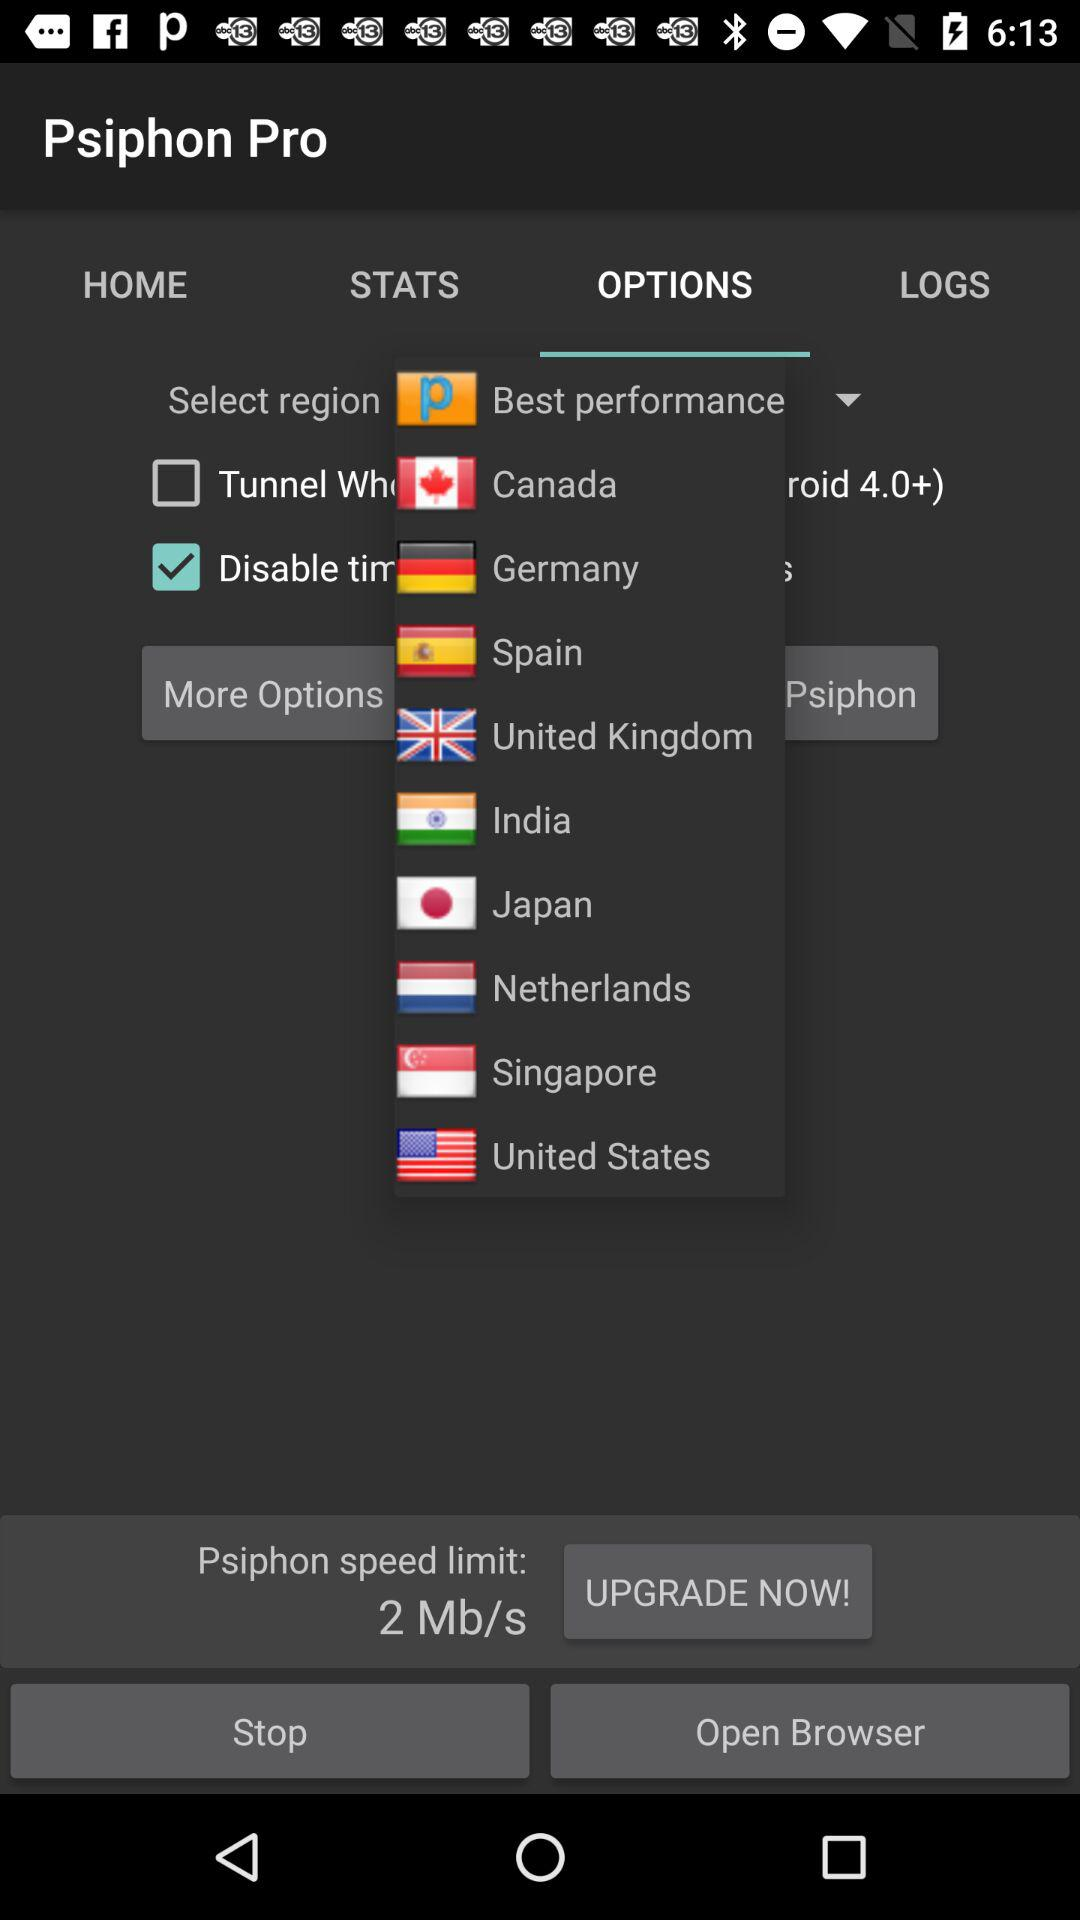Which tab is selected? The selected tab is "OPTIONS". 